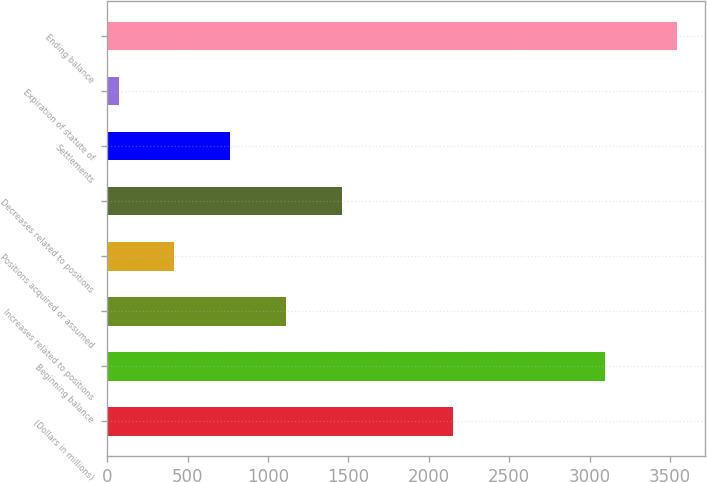<chart> <loc_0><loc_0><loc_500><loc_500><bar_chart><fcel>(Dollars in millions)<fcel>Beginning balance<fcel>Increases related to positions<fcel>Positions acquired or assumed<fcel>Decreases related to positions<fcel>Settlements<fcel>Expiration of statute of<fcel>Ending balance<nl><fcel>2153.4<fcel>3095<fcel>1112.7<fcel>418.9<fcel>1459.6<fcel>765.8<fcel>72<fcel>3541<nl></chart> 